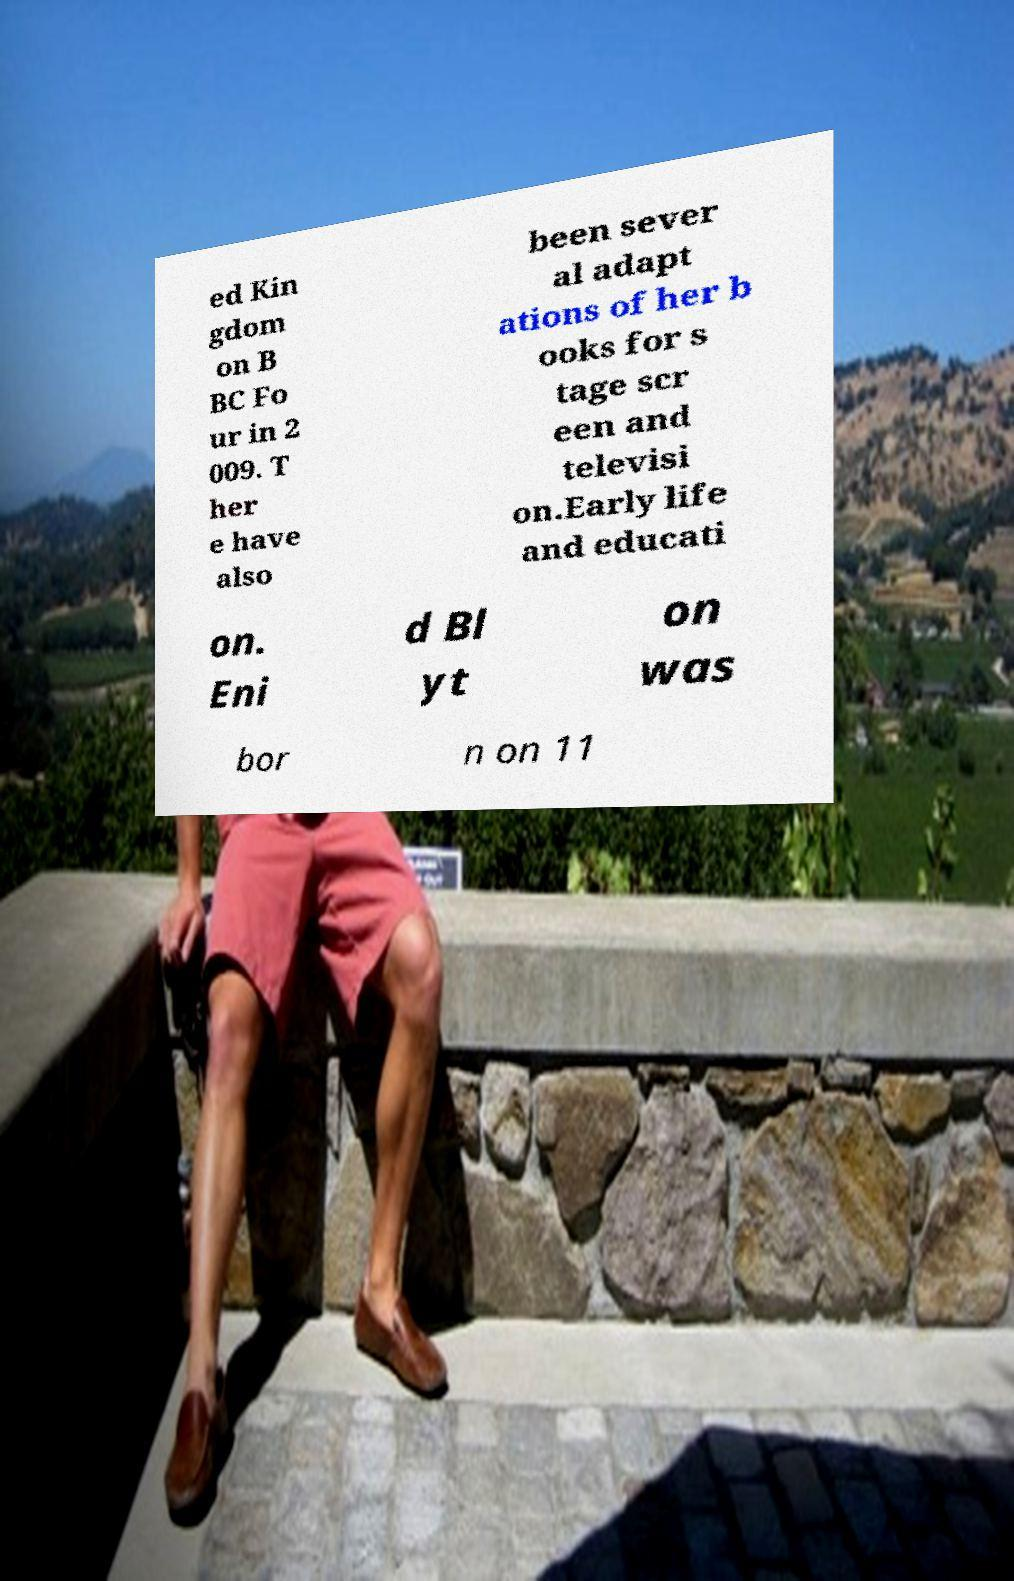I need the written content from this picture converted into text. Can you do that? ed Kin gdom on B BC Fo ur in 2 009. T her e have also been sever al adapt ations of her b ooks for s tage scr een and televisi on.Early life and educati on. Eni d Bl yt on was bor n on 11 